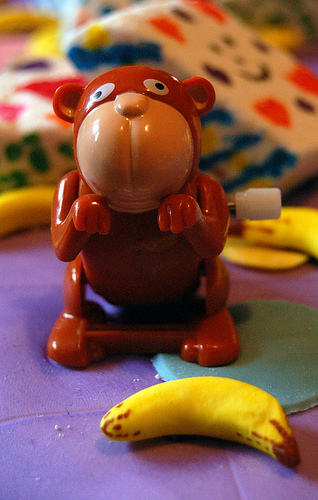<image>
Is the monkey on the banana? No. The monkey is not positioned on the banana. They may be near each other, but the monkey is not supported by or resting on top of the banana. 